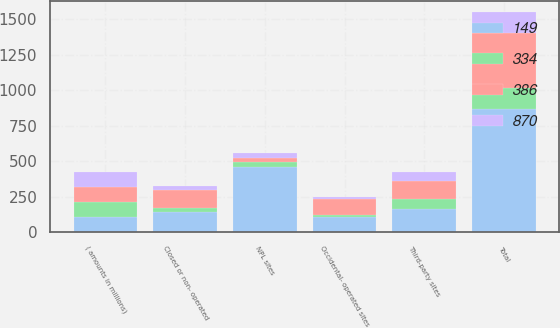<chart> <loc_0><loc_0><loc_500><loc_500><stacked_bar_chart><ecel><fcel>( amounts in millions)<fcel>NPL sites<fcel>Third-party sites<fcel>Occidental- operated sites<fcel>Closed or non- operated<fcel>Total<nl><fcel>334<fcel>106.5<fcel>33<fcel>68<fcel>17<fcel>29<fcel>147<nl><fcel>149<fcel>106.5<fcel>461<fcel>163<fcel>106<fcel>140<fcel>870<nl><fcel>870<fcel>106.5<fcel>34<fcel>66<fcel>18<fcel>31<fcel>149<nl><fcel>386<fcel>106.5<fcel>27<fcel>128<fcel>107<fcel>124<fcel>386<nl></chart> 